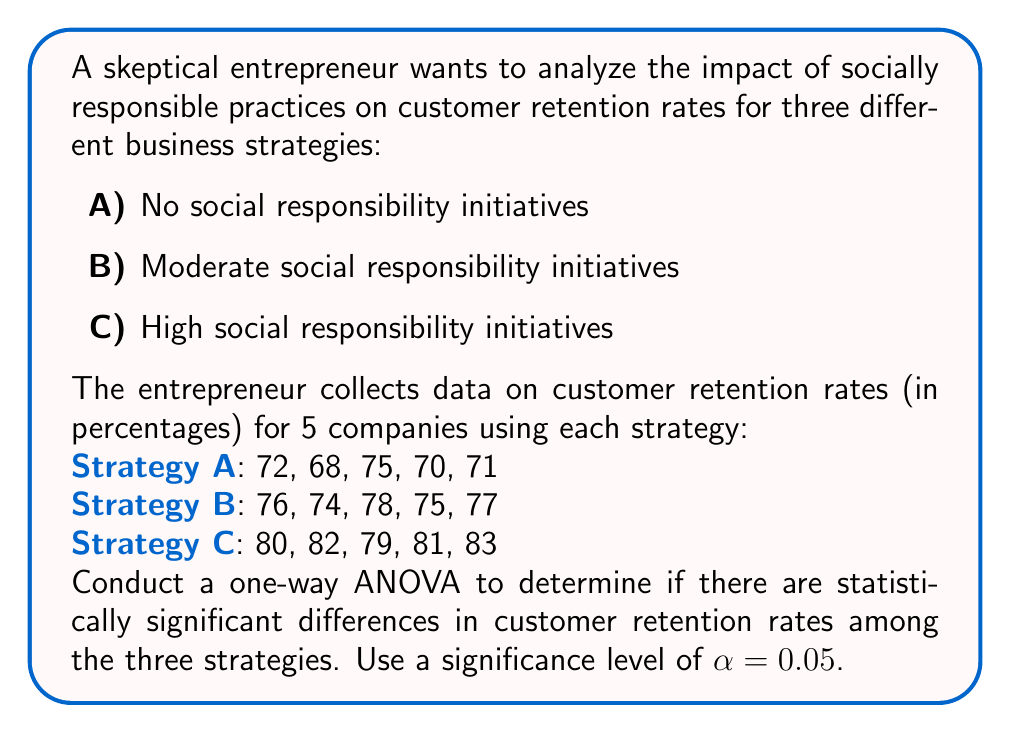Show me your answer to this math problem. To conduct a one-way ANOVA, we'll follow these steps:

1. Calculate the sum of squares between groups (SSB):
   $$SSB = \sum_{i=1}^k n_i(\bar{X_i} - \bar{X})^2$$
   where $k$ is the number of groups, $n_i$ is the sample size of each group, $\bar{X_i}$ is the mean of each group, and $\bar{X}$ is the grand mean.

2. Calculate the sum of squares within groups (SSW):
   $$SSW = \sum_{i=1}^k \sum_{j=1}^{n_i} (X_{ij} - \bar{X_i})^2$$
   where $X_{ij}$ is each individual observation.

3. Calculate the total sum of squares (SST):
   $$SST = SSB + SSW$$

4. Calculate degrees of freedom:
   $$df_B = k - 1$$
   $$df_W = N - k$$
   $$df_T = N - 1$$
   where $N$ is the total number of observations.

5. Calculate mean squares:
   $$MSB = \frac{SSB}{df_B}$$
   $$MSW = \frac{SSW}{df_W}$$

6. Calculate the F-statistic:
   $$F = \frac{MSB}{MSW}$$

7. Compare the F-statistic to the critical F-value.

Calculations:

Group means:
$\bar{X_A} = 71.2$, $\bar{X_B} = 76$, $\bar{X_C} = 81$

Grand mean: $\bar{X} = 76.07$

SSB = 5[(71.2 - 76.07)^2 + (76 - 76.07)^2 + (81 - 76.07)^2] = 240.13

SSW = [(72-71.2)^2 + ... + (83-81)^2] = 62.8

SST = 240.13 + 62.8 = 302.93

$df_B = 3 - 1 = 2$
$df_W = 15 - 3 = 12$
$df_T = 15 - 1 = 14$

MSB = 240.13 / 2 = 120.065
MSW = 62.8 / 12 = 5.23

F = 120.065 / 5.23 = 22.96

The critical F-value for α = 0.05, df_B = 2, and df_W = 12 is approximately 3.89.

Since 22.96 > 3.89, we reject the null hypothesis.
Answer: F(2, 12) = 22.96, p < 0.05. There is a statistically significant difference in customer retention rates among the three social responsibility strategies. 